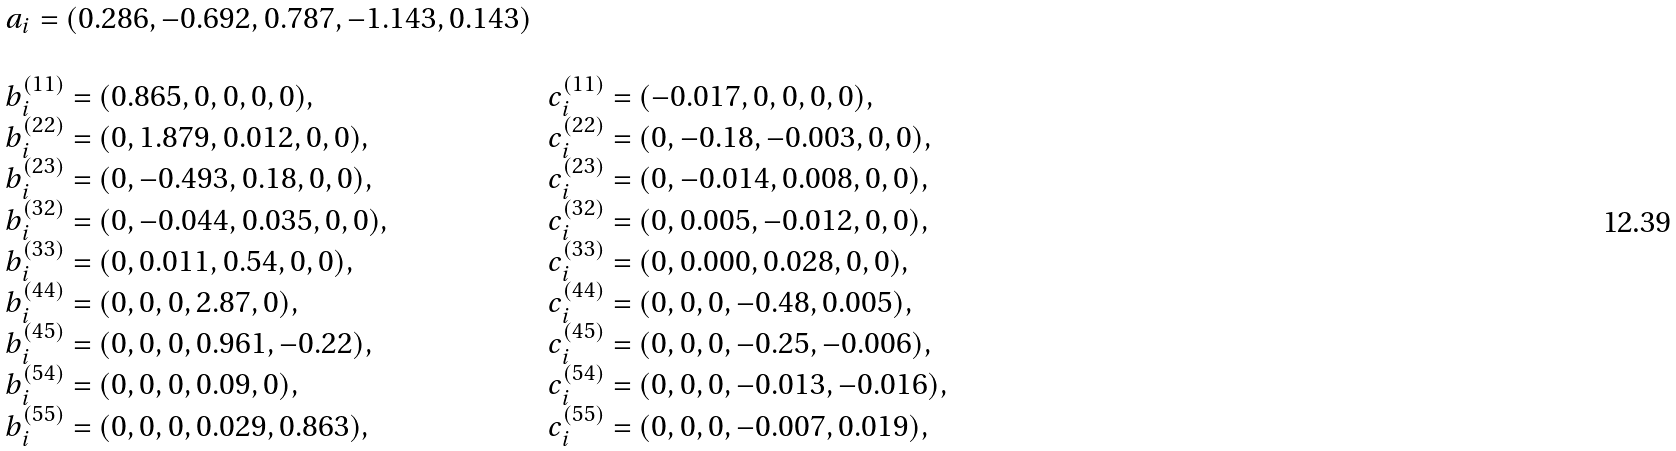Convert formula to latex. <formula><loc_0><loc_0><loc_500><loc_500>\begin{array} { l l } a _ { i } = ( 0 . 2 8 6 , - 0 . 6 9 2 , 0 . 7 8 7 , - 1 . 1 4 3 , 0 . 1 4 3 ) & \\ & \\ b ^ { ( 1 1 ) } _ { i } = ( 0 . 8 6 5 , 0 , 0 , 0 , 0 ) , & c ^ { ( 1 1 ) } _ { i } = ( - 0 . 0 1 7 , 0 , 0 , 0 , 0 ) , \\ b ^ { ( 2 2 ) } _ { i } = ( 0 , 1 . 8 7 9 , 0 . 0 1 2 , 0 , 0 ) , & c ^ { ( 2 2 ) } _ { i } = ( 0 , - 0 . 1 8 , - 0 . 0 0 3 , 0 , 0 ) , \\ b ^ { ( 2 3 ) } _ { i } = ( 0 , - 0 . 4 9 3 , 0 . 1 8 , 0 , 0 ) , & c ^ { ( 2 3 ) } _ { i } = ( 0 , - 0 . 0 1 4 , 0 . 0 0 8 , 0 , 0 ) , \\ b ^ { ( 3 2 ) } _ { i } = ( 0 , - 0 . 0 4 4 , 0 . 0 3 5 , 0 , 0 ) , & c ^ { ( 3 2 ) } _ { i } = ( 0 , 0 . 0 0 5 , - 0 . 0 1 2 , 0 , 0 ) , \\ b ^ { ( 3 3 ) } _ { i } = ( 0 , 0 . 0 1 1 , 0 . 5 4 , 0 , 0 ) , & c ^ { ( 3 3 ) } _ { i } = ( 0 , 0 . 0 0 0 , 0 . 0 2 8 , 0 , 0 ) , \\ b ^ { ( 4 4 ) } _ { i } = ( 0 , 0 , 0 , 2 . 8 7 , 0 ) , & c ^ { ( 4 4 ) } _ { i } = ( 0 , 0 , 0 , - 0 . 4 8 , 0 . 0 0 5 ) , \\ b ^ { ( 4 5 ) } _ { i } = ( 0 , 0 , 0 , 0 . 9 6 1 , - 0 . 2 2 ) , & c ^ { ( 4 5 ) } _ { i } = ( 0 , 0 , 0 , - 0 . 2 5 , - 0 . 0 0 6 ) , \\ b ^ { ( 5 4 ) } _ { i } = ( 0 , 0 , 0 , 0 . 0 9 , 0 ) , & c ^ { ( 5 4 ) } _ { i } = ( 0 , 0 , 0 , - 0 . 0 1 3 , - 0 . 0 1 6 ) , \\ b ^ { ( 5 5 ) } _ { i } = ( 0 , 0 , 0 , 0 . 0 2 9 , 0 . 8 6 3 ) , & c ^ { ( 5 5 ) } _ { i } = ( 0 , 0 , 0 , - 0 . 0 0 7 , 0 . 0 1 9 ) , \\ \end{array}</formula> 